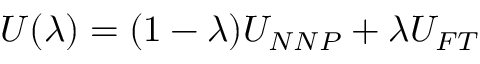<formula> <loc_0><loc_0><loc_500><loc_500>U ( \lambda ) = ( 1 - \lambda ) U _ { N N P } + \lambda U _ { F T }</formula> 